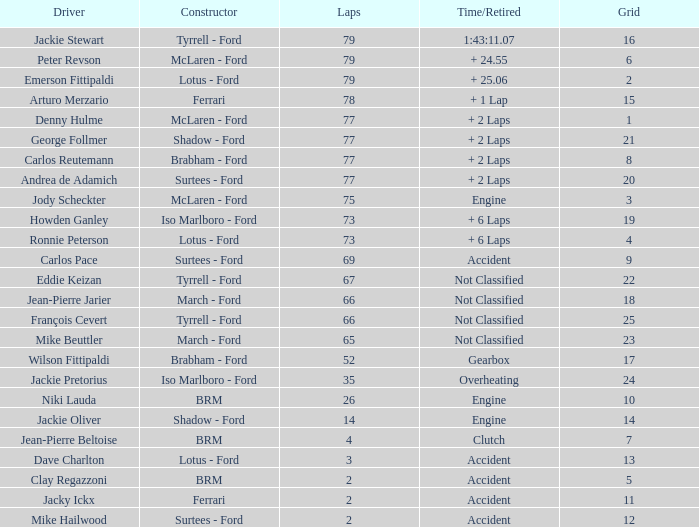What is the total grid with laps less than 2? None. 